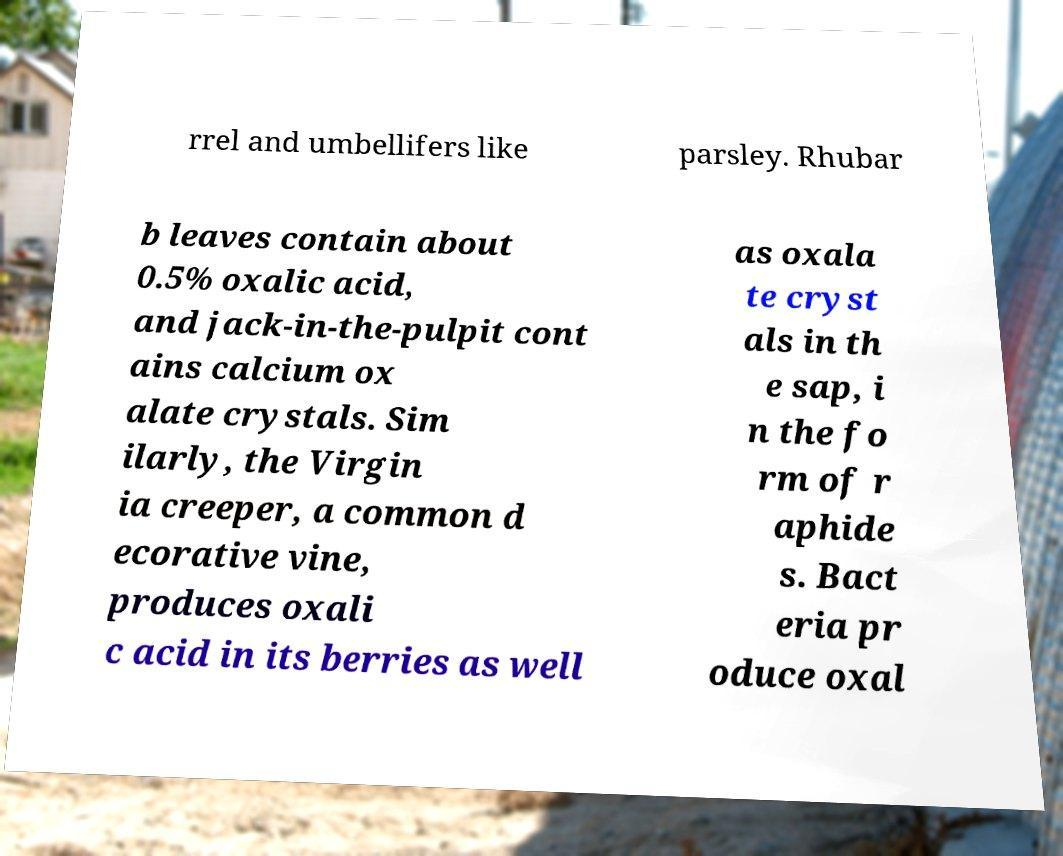Can you read and provide the text displayed in the image?This photo seems to have some interesting text. Can you extract and type it out for me? rrel and umbellifers like parsley. Rhubar b leaves contain about 0.5% oxalic acid, and jack-in-the-pulpit cont ains calcium ox alate crystals. Sim ilarly, the Virgin ia creeper, a common d ecorative vine, produces oxali c acid in its berries as well as oxala te cryst als in th e sap, i n the fo rm of r aphide s. Bact eria pr oduce oxal 